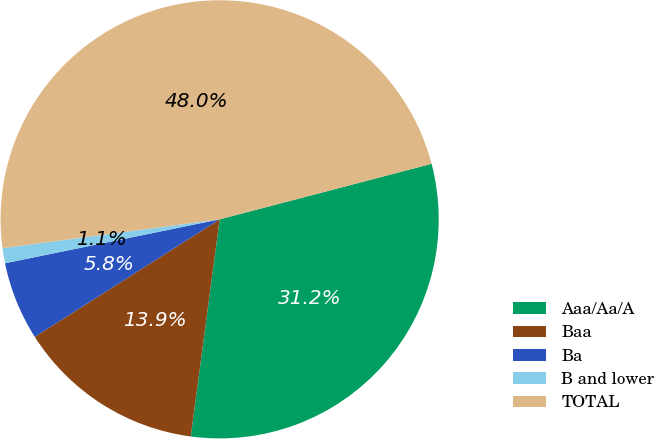Convert chart. <chart><loc_0><loc_0><loc_500><loc_500><pie_chart><fcel>Aaa/Aa/A<fcel>Baa<fcel>Ba<fcel>B and lower<fcel>TOTAL<nl><fcel>31.18%<fcel>13.88%<fcel>5.8%<fcel>1.11%<fcel>48.02%<nl></chart> 